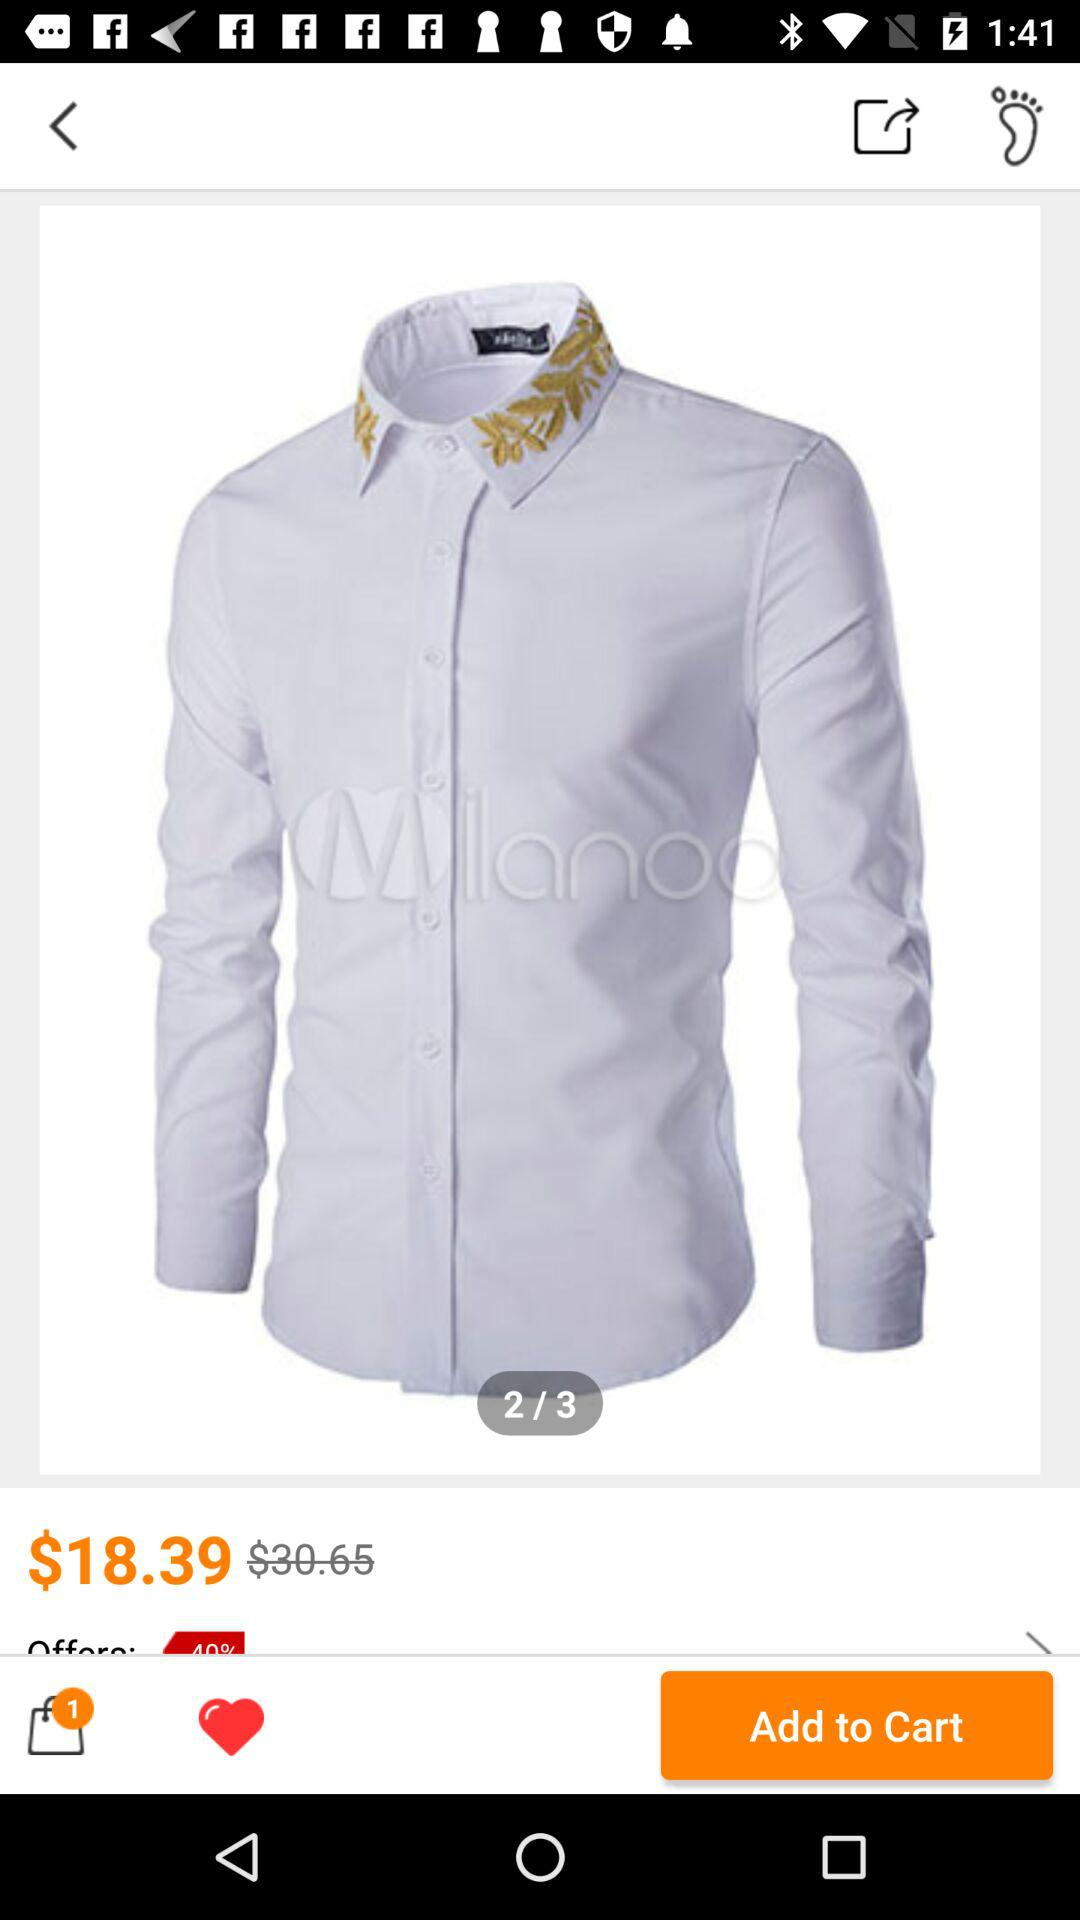How many items are in the shopping bag?
Answer the question using a single word or phrase. 1 